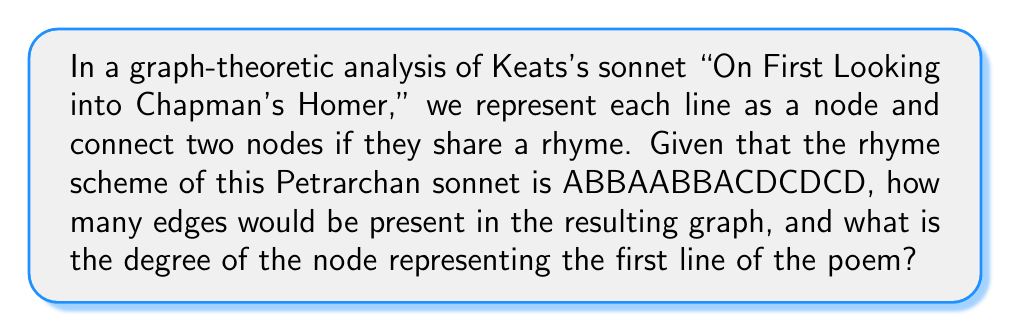Could you help me with this problem? Let's approach this step-by-step:

1) First, let's identify the rhyme structure:
   A: lines 1, 4, 5, 8
   B: lines 2, 3, 6, 7
   C: lines 9, 12, 14
   D: lines 10, 11, 13

2) To calculate the number of edges, we need to connect every node to all other nodes with the same rhyme:

   For A: $\binom{4}{2} = 6$ edges
   For B: $\binom{4}{2} = 6$ edges
   For C: $\binom{3}{2} = 3$ edges
   For D: $\binom{3}{2} = 3$ edges

3) Total number of edges: $6 + 6 + 3 + 3 = 18$

4) To find the degree of the node representing the first line:
   - The first line rhymes with lines 4, 5, and 8
   - Therefore, it will be connected to 3 other nodes

Thus, the degree of the node representing the first line is 3.
Answer: 18 edges; degree 3 